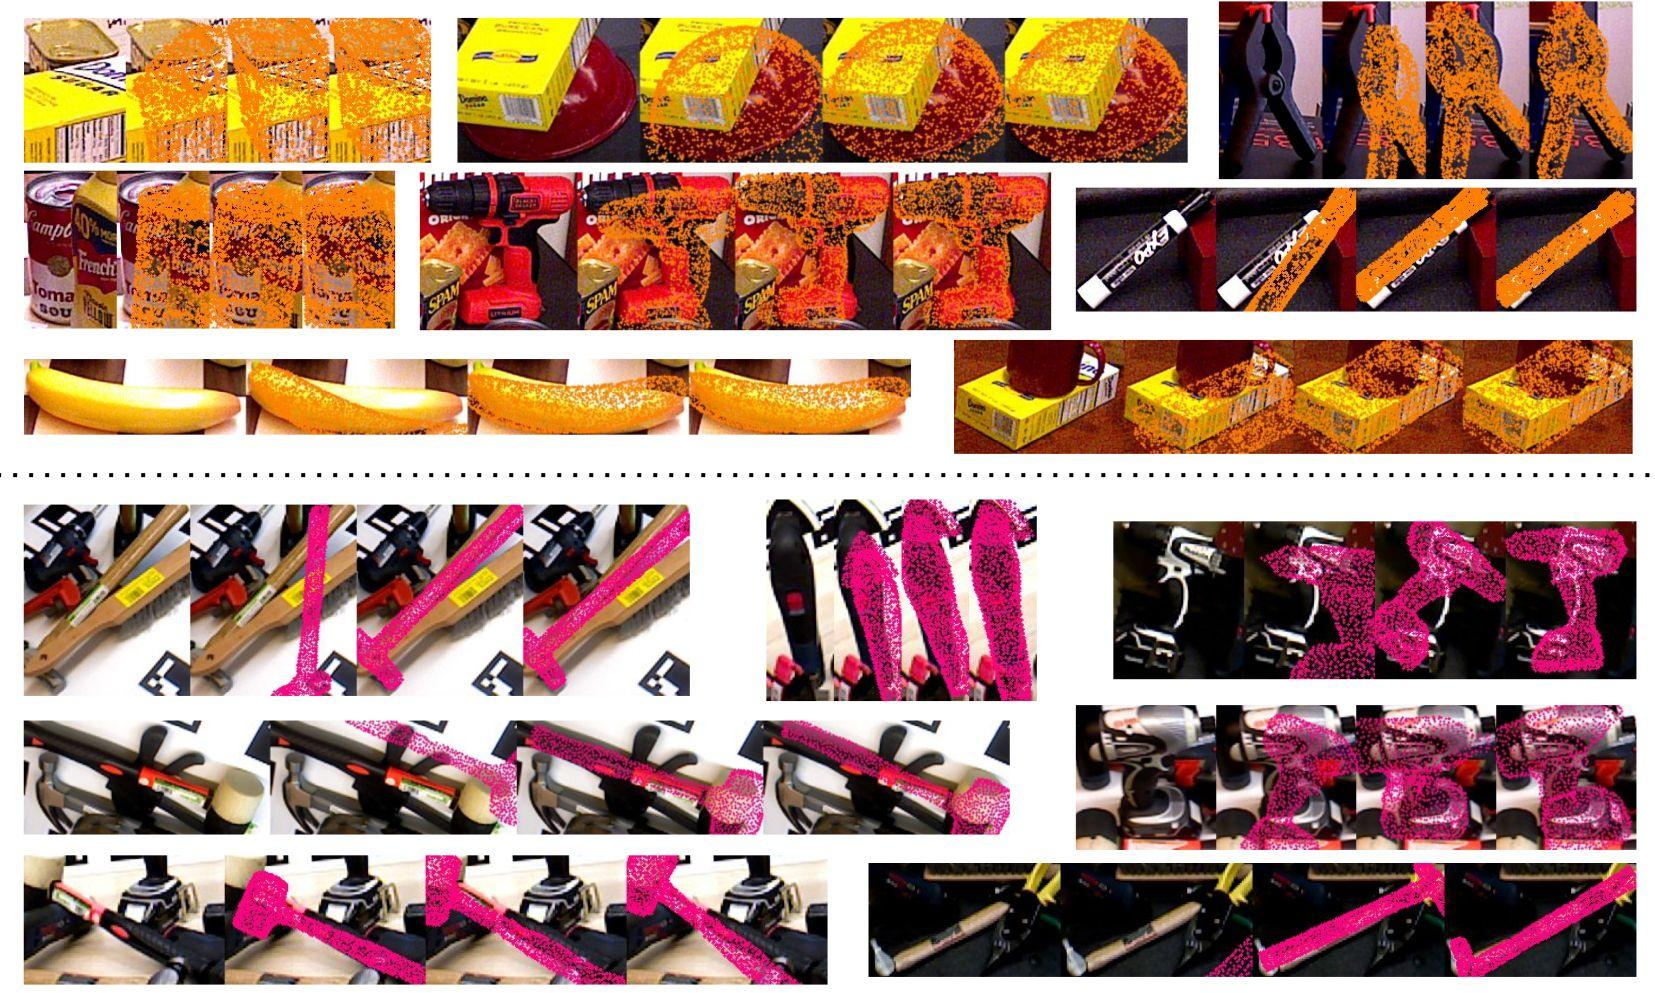Can you suggest some methods to restore or mitigate the corruption observed in these images? Restoring or mitigating image corruption can be approached through various techniques. In the case of horizontal stripe corruption, one might employ signal processing methods such as Fourier analysis to isolate and remove the corrupting frequencies. Machine learning algorithms, particularly those in the realm of deep learning like convolutional neural networks, can be trained to recognize and reconstruct the missing or distorted parts of an image. Additionally, error correction codes are often used in digital transmission to detect and correct corruption. Prevention is also key, and includes regular data integrity checks and using formats and storage methods that minimize the risk of such corruption. 